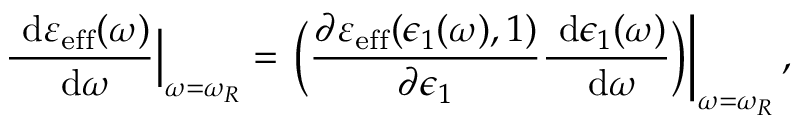<formula> <loc_0><loc_0><loc_500><loc_500>\frac { \ d \varepsilon _ { e f f } ( \omega ) } { \ d \omega } \Big | _ { \omega = \omega _ { R } } = \Big ( \frac { \partial \varepsilon _ { e f f } ( \epsilon _ { 1 } ( \omega ) , 1 ) } { \partial \epsilon _ { 1 } } \frac { \ d \epsilon _ { 1 } ( \omega ) } { \ d \omega } \Big ) \right | _ { \omega = \omega _ { R } } ,</formula> 